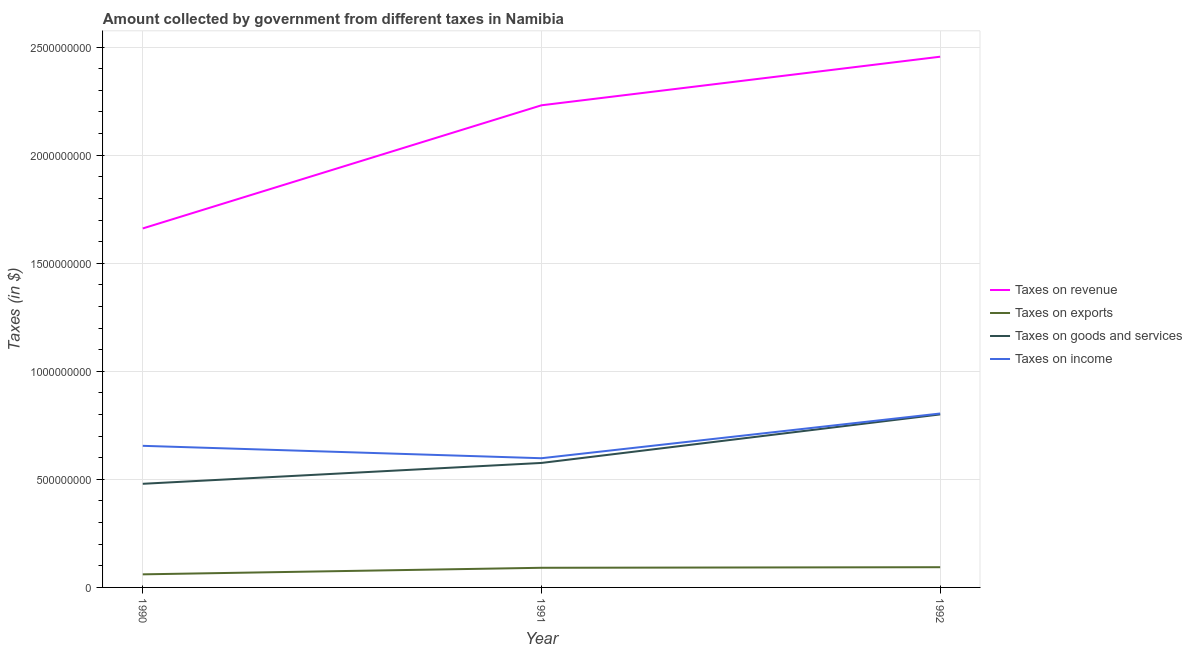Does the line corresponding to amount collected as tax on income intersect with the line corresponding to amount collected as tax on goods?
Offer a very short reply. No. What is the amount collected as tax on exports in 1992?
Make the answer very short. 9.36e+07. Across all years, what is the maximum amount collected as tax on revenue?
Your answer should be very brief. 2.46e+09. Across all years, what is the minimum amount collected as tax on revenue?
Offer a very short reply. 1.66e+09. What is the total amount collected as tax on revenue in the graph?
Offer a terse response. 6.35e+09. What is the difference between the amount collected as tax on income in 1990 and that in 1991?
Your answer should be very brief. 5.74e+07. What is the difference between the amount collected as tax on revenue in 1992 and the amount collected as tax on exports in 1991?
Offer a terse response. 2.36e+09. What is the average amount collected as tax on income per year?
Offer a terse response. 6.86e+08. In the year 1992, what is the difference between the amount collected as tax on income and amount collected as tax on goods?
Give a very brief answer. 4.20e+06. In how many years, is the amount collected as tax on exports greater than 100000000 $?
Offer a terse response. 0. What is the ratio of the amount collected as tax on income in 1991 to that in 1992?
Your answer should be very brief. 0.74. What is the difference between the highest and the second highest amount collected as tax on goods?
Offer a very short reply. 2.24e+08. What is the difference between the highest and the lowest amount collected as tax on exports?
Your answer should be compact. 3.31e+07. In how many years, is the amount collected as tax on exports greater than the average amount collected as tax on exports taken over all years?
Your answer should be compact. 2. Does the amount collected as tax on revenue monotonically increase over the years?
Your response must be concise. Yes. How many years are there in the graph?
Your answer should be compact. 3. Does the graph contain grids?
Ensure brevity in your answer.  Yes. Where does the legend appear in the graph?
Make the answer very short. Center right. How many legend labels are there?
Ensure brevity in your answer.  4. How are the legend labels stacked?
Offer a very short reply. Vertical. What is the title of the graph?
Ensure brevity in your answer.  Amount collected by government from different taxes in Namibia. What is the label or title of the Y-axis?
Your response must be concise. Taxes (in $). What is the Taxes (in $) in Taxes on revenue in 1990?
Give a very brief answer. 1.66e+09. What is the Taxes (in $) of Taxes on exports in 1990?
Offer a terse response. 6.05e+07. What is the Taxes (in $) in Taxes on goods and services in 1990?
Give a very brief answer. 4.80e+08. What is the Taxes (in $) in Taxes on income in 1990?
Provide a succinct answer. 6.55e+08. What is the Taxes (in $) in Taxes on revenue in 1991?
Provide a succinct answer. 2.23e+09. What is the Taxes (in $) in Taxes on exports in 1991?
Ensure brevity in your answer.  9.09e+07. What is the Taxes (in $) in Taxes on goods and services in 1991?
Make the answer very short. 5.76e+08. What is the Taxes (in $) in Taxes on income in 1991?
Give a very brief answer. 5.98e+08. What is the Taxes (in $) in Taxes on revenue in 1992?
Your response must be concise. 2.46e+09. What is the Taxes (in $) of Taxes on exports in 1992?
Keep it short and to the point. 9.36e+07. What is the Taxes (in $) in Taxes on goods and services in 1992?
Offer a terse response. 8.00e+08. What is the Taxes (in $) of Taxes on income in 1992?
Your answer should be compact. 8.05e+08. Across all years, what is the maximum Taxes (in $) of Taxes on revenue?
Make the answer very short. 2.46e+09. Across all years, what is the maximum Taxes (in $) in Taxes on exports?
Provide a short and direct response. 9.36e+07. Across all years, what is the maximum Taxes (in $) in Taxes on goods and services?
Your response must be concise. 8.00e+08. Across all years, what is the maximum Taxes (in $) of Taxes on income?
Make the answer very short. 8.05e+08. Across all years, what is the minimum Taxes (in $) in Taxes on revenue?
Provide a succinct answer. 1.66e+09. Across all years, what is the minimum Taxes (in $) in Taxes on exports?
Provide a short and direct response. 6.05e+07. Across all years, what is the minimum Taxes (in $) in Taxes on goods and services?
Offer a terse response. 4.80e+08. Across all years, what is the minimum Taxes (in $) in Taxes on income?
Your answer should be very brief. 5.98e+08. What is the total Taxes (in $) of Taxes on revenue in the graph?
Give a very brief answer. 6.35e+09. What is the total Taxes (in $) in Taxes on exports in the graph?
Give a very brief answer. 2.45e+08. What is the total Taxes (in $) of Taxes on goods and services in the graph?
Offer a very short reply. 1.86e+09. What is the total Taxes (in $) in Taxes on income in the graph?
Keep it short and to the point. 2.06e+09. What is the difference between the Taxes (in $) of Taxes on revenue in 1990 and that in 1991?
Your answer should be very brief. -5.70e+08. What is the difference between the Taxes (in $) of Taxes on exports in 1990 and that in 1991?
Your response must be concise. -3.04e+07. What is the difference between the Taxes (in $) in Taxes on goods and services in 1990 and that in 1991?
Offer a terse response. -9.65e+07. What is the difference between the Taxes (in $) of Taxes on income in 1990 and that in 1991?
Your answer should be very brief. 5.74e+07. What is the difference between the Taxes (in $) of Taxes on revenue in 1990 and that in 1992?
Give a very brief answer. -7.95e+08. What is the difference between the Taxes (in $) in Taxes on exports in 1990 and that in 1992?
Keep it short and to the point. -3.31e+07. What is the difference between the Taxes (in $) of Taxes on goods and services in 1990 and that in 1992?
Give a very brief answer. -3.21e+08. What is the difference between the Taxes (in $) of Taxes on income in 1990 and that in 1992?
Provide a succinct answer. -1.50e+08. What is the difference between the Taxes (in $) of Taxes on revenue in 1991 and that in 1992?
Offer a very short reply. -2.25e+08. What is the difference between the Taxes (in $) in Taxes on exports in 1991 and that in 1992?
Ensure brevity in your answer.  -2.70e+06. What is the difference between the Taxes (in $) of Taxes on goods and services in 1991 and that in 1992?
Your response must be concise. -2.24e+08. What is the difference between the Taxes (in $) of Taxes on income in 1991 and that in 1992?
Keep it short and to the point. -2.07e+08. What is the difference between the Taxes (in $) of Taxes on revenue in 1990 and the Taxes (in $) of Taxes on exports in 1991?
Keep it short and to the point. 1.57e+09. What is the difference between the Taxes (in $) of Taxes on revenue in 1990 and the Taxes (in $) of Taxes on goods and services in 1991?
Keep it short and to the point. 1.08e+09. What is the difference between the Taxes (in $) in Taxes on revenue in 1990 and the Taxes (in $) in Taxes on income in 1991?
Provide a short and direct response. 1.06e+09. What is the difference between the Taxes (in $) in Taxes on exports in 1990 and the Taxes (in $) in Taxes on goods and services in 1991?
Give a very brief answer. -5.16e+08. What is the difference between the Taxes (in $) of Taxes on exports in 1990 and the Taxes (in $) of Taxes on income in 1991?
Provide a succinct answer. -5.37e+08. What is the difference between the Taxes (in $) in Taxes on goods and services in 1990 and the Taxes (in $) in Taxes on income in 1991?
Your response must be concise. -1.18e+08. What is the difference between the Taxes (in $) of Taxes on revenue in 1990 and the Taxes (in $) of Taxes on exports in 1992?
Your response must be concise. 1.57e+09. What is the difference between the Taxes (in $) of Taxes on revenue in 1990 and the Taxes (in $) of Taxes on goods and services in 1992?
Your answer should be compact. 8.60e+08. What is the difference between the Taxes (in $) in Taxes on revenue in 1990 and the Taxes (in $) in Taxes on income in 1992?
Make the answer very short. 8.56e+08. What is the difference between the Taxes (in $) of Taxes on exports in 1990 and the Taxes (in $) of Taxes on goods and services in 1992?
Ensure brevity in your answer.  -7.40e+08. What is the difference between the Taxes (in $) of Taxes on exports in 1990 and the Taxes (in $) of Taxes on income in 1992?
Make the answer very short. -7.44e+08. What is the difference between the Taxes (in $) of Taxes on goods and services in 1990 and the Taxes (in $) of Taxes on income in 1992?
Offer a very short reply. -3.25e+08. What is the difference between the Taxes (in $) of Taxes on revenue in 1991 and the Taxes (in $) of Taxes on exports in 1992?
Offer a very short reply. 2.14e+09. What is the difference between the Taxes (in $) of Taxes on revenue in 1991 and the Taxes (in $) of Taxes on goods and services in 1992?
Provide a succinct answer. 1.43e+09. What is the difference between the Taxes (in $) of Taxes on revenue in 1991 and the Taxes (in $) of Taxes on income in 1992?
Provide a succinct answer. 1.43e+09. What is the difference between the Taxes (in $) in Taxes on exports in 1991 and the Taxes (in $) in Taxes on goods and services in 1992?
Make the answer very short. -7.10e+08. What is the difference between the Taxes (in $) of Taxes on exports in 1991 and the Taxes (in $) of Taxes on income in 1992?
Keep it short and to the point. -7.14e+08. What is the difference between the Taxes (in $) of Taxes on goods and services in 1991 and the Taxes (in $) of Taxes on income in 1992?
Ensure brevity in your answer.  -2.29e+08. What is the average Taxes (in $) of Taxes on revenue per year?
Your response must be concise. 2.12e+09. What is the average Taxes (in $) in Taxes on exports per year?
Provide a succinct answer. 8.17e+07. What is the average Taxes (in $) of Taxes on goods and services per year?
Offer a very short reply. 6.19e+08. What is the average Taxes (in $) in Taxes on income per year?
Offer a very short reply. 6.86e+08. In the year 1990, what is the difference between the Taxes (in $) of Taxes on revenue and Taxes (in $) of Taxes on exports?
Ensure brevity in your answer.  1.60e+09. In the year 1990, what is the difference between the Taxes (in $) in Taxes on revenue and Taxes (in $) in Taxes on goods and services?
Offer a terse response. 1.18e+09. In the year 1990, what is the difference between the Taxes (in $) of Taxes on revenue and Taxes (in $) of Taxes on income?
Ensure brevity in your answer.  1.01e+09. In the year 1990, what is the difference between the Taxes (in $) of Taxes on exports and Taxes (in $) of Taxes on goods and services?
Make the answer very short. -4.19e+08. In the year 1990, what is the difference between the Taxes (in $) in Taxes on exports and Taxes (in $) in Taxes on income?
Make the answer very short. -5.95e+08. In the year 1990, what is the difference between the Taxes (in $) of Taxes on goods and services and Taxes (in $) of Taxes on income?
Your answer should be very brief. -1.76e+08. In the year 1991, what is the difference between the Taxes (in $) in Taxes on revenue and Taxes (in $) in Taxes on exports?
Your answer should be compact. 2.14e+09. In the year 1991, what is the difference between the Taxes (in $) of Taxes on revenue and Taxes (in $) of Taxes on goods and services?
Provide a short and direct response. 1.65e+09. In the year 1991, what is the difference between the Taxes (in $) in Taxes on revenue and Taxes (in $) in Taxes on income?
Keep it short and to the point. 1.63e+09. In the year 1991, what is the difference between the Taxes (in $) in Taxes on exports and Taxes (in $) in Taxes on goods and services?
Offer a terse response. -4.85e+08. In the year 1991, what is the difference between the Taxes (in $) of Taxes on exports and Taxes (in $) of Taxes on income?
Provide a succinct answer. -5.07e+08. In the year 1991, what is the difference between the Taxes (in $) of Taxes on goods and services and Taxes (in $) of Taxes on income?
Your answer should be very brief. -2.18e+07. In the year 1992, what is the difference between the Taxes (in $) of Taxes on revenue and Taxes (in $) of Taxes on exports?
Offer a terse response. 2.36e+09. In the year 1992, what is the difference between the Taxes (in $) of Taxes on revenue and Taxes (in $) of Taxes on goods and services?
Keep it short and to the point. 1.66e+09. In the year 1992, what is the difference between the Taxes (in $) in Taxes on revenue and Taxes (in $) in Taxes on income?
Offer a terse response. 1.65e+09. In the year 1992, what is the difference between the Taxes (in $) of Taxes on exports and Taxes (in $) of Taxes on goods and services?
Provide a succinct answer. -7.07e+08. In the year 1992, what is the difference between the Taxes (in $) of Taxes on exports and Taxes (in $) of Taxes on income?
Your response must be concise. -7.11e+08. In the year 1992, what is the difference between the Taxes (in $) of Taxes on goods and services and Taxes (in $) of Taxes on income?
Offer a very short reply. -4.20e+06. What is the ratio of the Taxes (in $) of Taxes on revenue in 1990 to that in 1991?
Provide a succinct answer. 0.74. What is the ratio of the Taxes (in $) in Taxes on exports in 1990 to that in 1991?
Your response must be concise. 0.67. What is the ratio of the Taxes (in $) in Taxes on goods and services in 1990 to that in 1991?
Give a very brief answer. 0.83. What is the ratio of the Taxes (in $) in Taxes on income in 1990 to that in 1991?
Your response must be concise. 1.1. What is the ratio of the Taxes (in $) in Taxes on revenue in 1990 to that in 1992?
Offer a very short reply. 0.68. What is the ratio of the Taxes (in $) in Taxes on exports in 1990 to that in 1992?
Your response must be concise. 0.65. What is the ratio of the Taxes (in $) in Taxes on goods and services in 1990 to that in 1992?
Keep it short and to the point. 0.6. What is the ratio of the Taxes (in $) in Taxes on income in 1990 to that in 1992?
Your answer should be compact. 0.81. What is the ratio of the Taxes (in $) of Taxes on revenue in 1991 to that in 1992?
Give a very brief answer. 0.91. What is the ratio of the Taxes (in $) of Taxes on exports in 1991 to that in 1992?
Provide a short and direct response. 0.97. What is the ratio of the Taxes (in $) of Taxes on goods and services in 1991 to that in 1992?
Your answer should be compact. 0.72. What is the ratio of the Taxes (in $) of Taxes on income in 1991 to that in 1992?
Provide a succinct answer. 0.74. What is the difference between the highest and the second highest Taxes (in $) in Taxes on revenue?
Provide a short and direct response. 2.25e+08. What is the difference between the highest and the second highest Taxes (in $) in Taxes on exports?
Offer a very short reply. 2.70e+06. What is the difference between the highest and the second highest Taxes (in $) of Taxes on goods and services?
Provide a short and direct response. 2.24e+08. What is the difference between the highest and the second highest Taxes (in $) of Taxes on income?
Make the answer very short. 1.50e+08. What is the difference between the highest and the lowest Taxes (in $) in Taxes on revenue?
Your answer should be very brief. 7.95e+08. What is the difference between the highest and the lowest Taxes (in $) of Taxes on exports?
Your answer should be compact. 3.31e+07. What is the difference between the highest and the lowest Taxes (in $) in Taxes on goods and services?
Your answer should be compact. 3.21e+08. What is the difference between the highest and the lowest Taxes (in $) of Taxes on income?
Make the answer very short. 2.07e+08. 